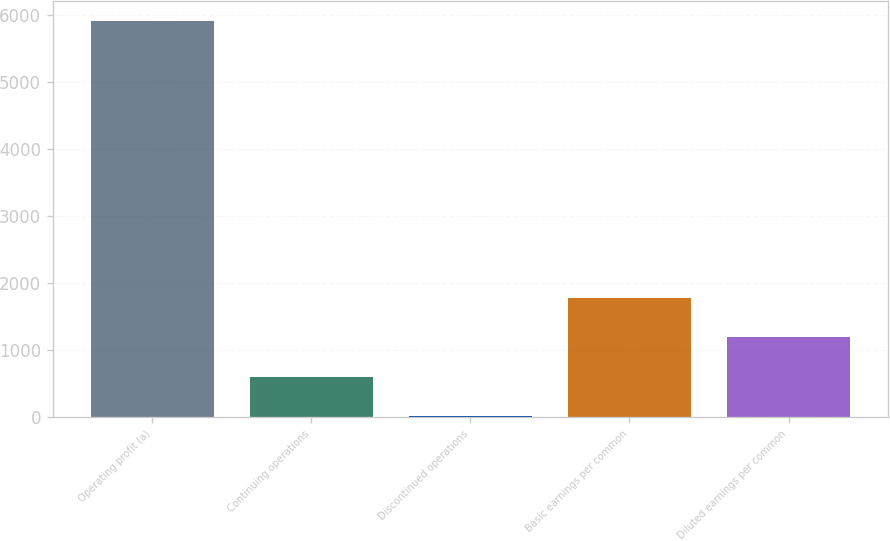Convert chart. <chart><loc_0><loc_0><loc_500><loc_500><bar_chart><fcel>Operating profit (a)<fcel>Continuing operations<fcel>Discontinued operations<fcel>Basic earnings per common<fcel>Diluted earnings per common<nl><fcel>5910<fcel>595.54<fcel>5.05<fcel>1776.53<fcel>1186.03<nl></chart> 